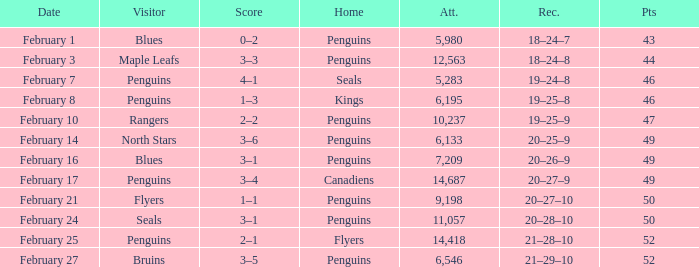Help me parse the entirety of this table. {'header': ['Date', 'Visitor', 'Score', 'Home', 'Att.', 'Rec.', 'Pts'], 'rows': [['February 1', 'Blues', '0–2', 'Penguins', '5,980', '18–24–7', '43'], ['February 3', 'Maple Leafs', '3–3', 'Penguins', '12,563', '18–24–8', '44'], ['February 7', 'Penguins', '4–1', 'Seals', '5,283', '19–24–8', '46'], ['February 8', 'Penguins', '1–3', 'Kings', '6,195', '19–25–8', '46'], ['February 10', 'Rangers', '2–2', 'Penguins', '10,237', '19–25–9', '47'], ['February 14', 'North Stars', '3–6', 'Penguins', '6,133', '20–25–9', '49'], ['February 16', 'Blues', '3–1', 'Penguins', '7,209', '20–26–9', '49'], ['February 17', 'Penguins', '3–4', 'Canadiens', '14,687', '20–27–9', '49'], ['February 21', 'Flyers', '1–1', 'Penguins', '9,198', '20–27–10', '50'], ['February 24', 'Seals', '3–1', 'Penguins', '11,057', '20–28–10', '50'], ['February 25', 'Penguins', '2–1', 'Flyers', '14,418', '21–28–10', '52'], ['February 27', 'Bruins', '3–5', 'Penguins', '6,546', '21–29–10', '52']]} Score of 2–1 has what record? 21–28–10. 